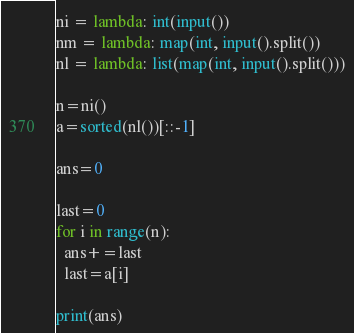Convert code to text. <code><loc_0><loc_0><loc_500><loc_500><_Python_>ni = lambda: int(input())
nm = lambda: map(int, input().split())
nl = lambda: list(map(int, input().split()))

n=ni()
a=sorted(nl())[::-1]

ans=0

last=0
for i in range(n):
  ans+=last
  last=a[i]

print(ans)
</code> 